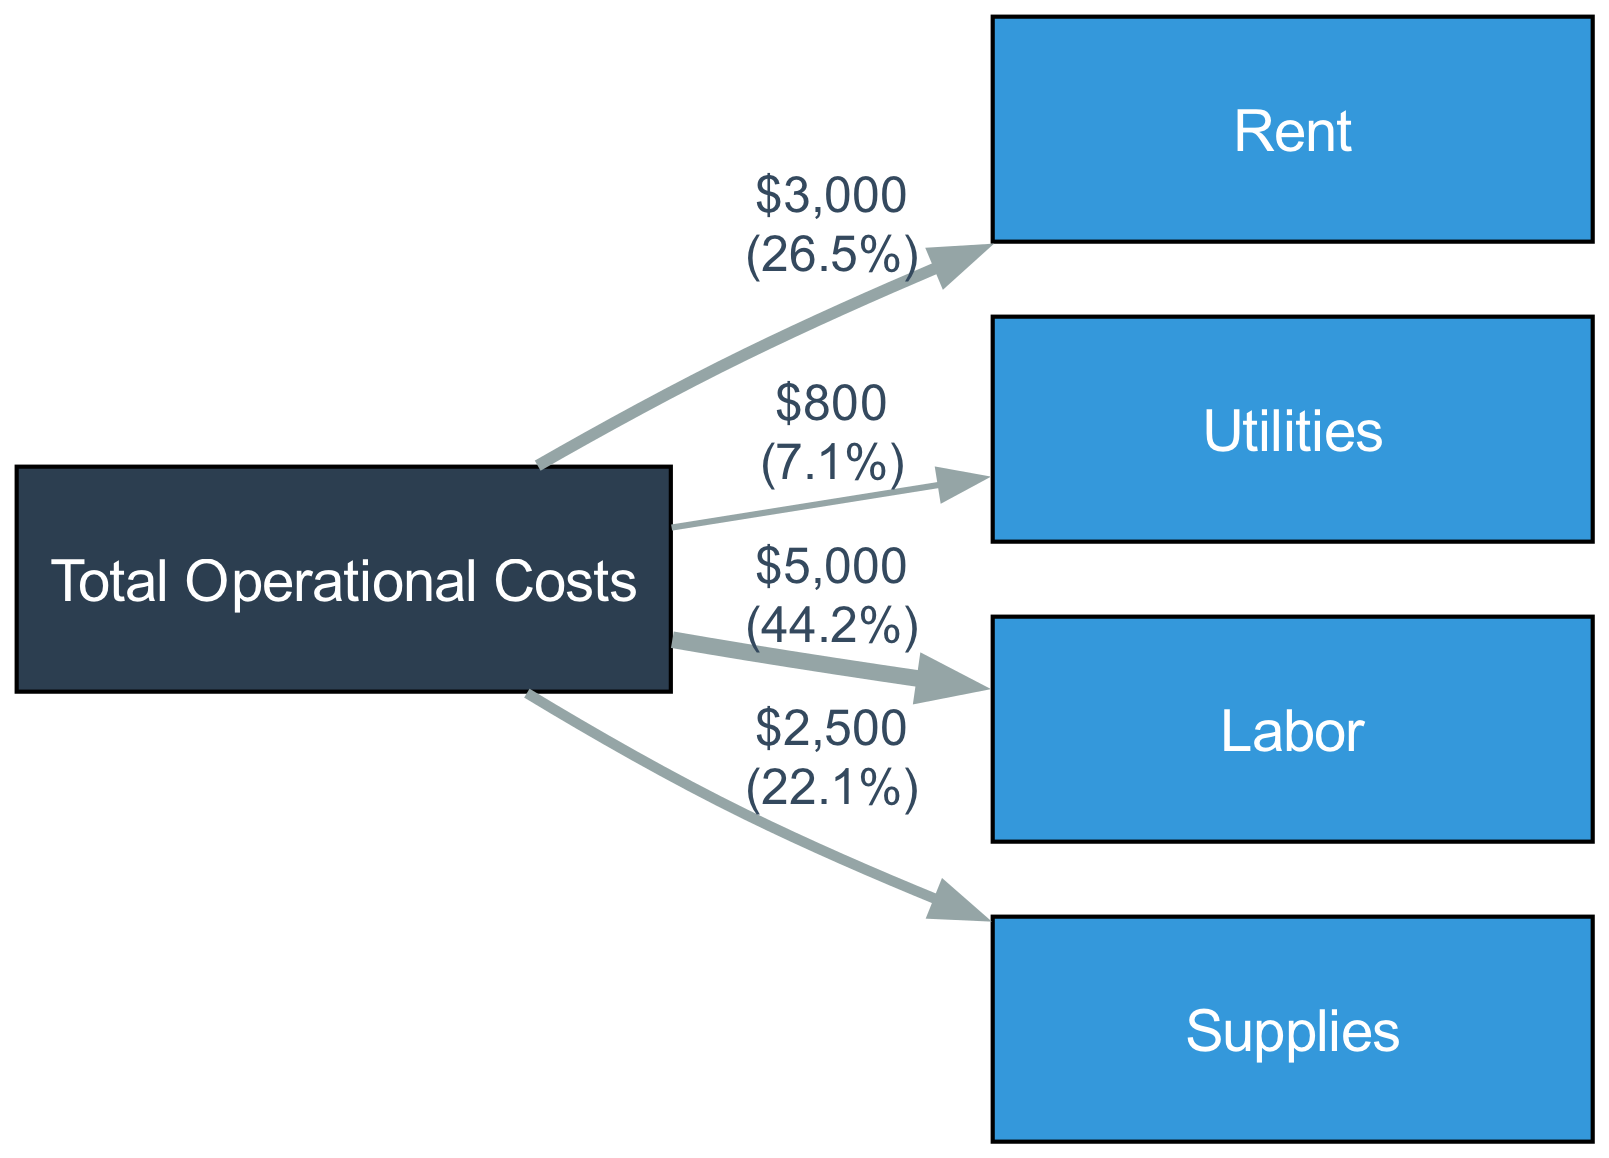What is the total operational cost for June 2023? The total operational cost is the sum of all the costs linked from the "Total Operational Costs" node. From the diagram, Rent is $3000, Utilities is $800, Labor is $5000, and Supplies is $2500. Adding these values together gives: 3000 + 800 + 5000 + 2500 = 11100
Answer: 11100 How much is spent on labor? Labor is a specific cost node linked from the "Total Operational Costs." According to the diagram, the value associated with Labor is $5000.
Answer: 5000 What percentage of the total costs does rent account for? To find the percentage of rent in the total operational costs, take the rent amount of $3000 and divide it by the total operational costs of $11100. Then multiply by 100 to find the percentage: (3000 / 11100) * 100 = approximately 27.0%.
Answer: 27.0% Which cost category has the highest expenditure? By comparing the values linked to each cost category, we see that Rent is $3000, Utilities is $800, Labor is $5000, and Supplies is $2500. The highest expenditure is Labor at $5000.
Answer: Labor How many edges are present in the diagram? The edges represent the links from the "Total Operational Costs" node to each of the cost categories. Counting the links given in the diagram, there are 4 edges: Rent, Utilities, Labor, and Supplies.
Answer: 4 What is the value of supplies? The supplies node, connected to total operational costs, has a value of $2500 as shown in the links.
Answer: 2500 How does the expenditure on utilities compare to rent? To compare utilities to rent, we can look at their values: Rent is $3000 and Utilities is $800. Rent is significantly higher than Utilities. Specifically, Rent is more than three times the amount of Utilities.
Answer: Rent is higher What is the total spent on both Rent and Supplies together? To find the total for Rent and Supplies, we take their individual values. Rent is $3000 and Supplies is $2500. Adding these values together gives: 3000 + 2500 = 5500.
Answer: 5500 What is the link color used in this diagram? The links in the diagram are colored with a hex value of #95A5A6, as mentioned in the code for rendering the edges.
Answer: #95A5A6 